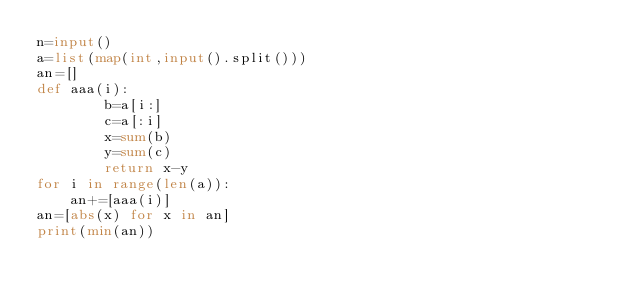<code> <loc_0><loc_0><loc_500><loc_500><_Python_>n=input()
a=list(map(int,input().split()))
an=[]
def aaa(i):
        b=a[i:]
        c=a[:i]
        x=sum(b)
        y=sum(c)
        return x-y
for i in range(len(a)):
    an+=[aaa(i)]
an=[abs(x) for x in an]
print(min(an))
</code> 